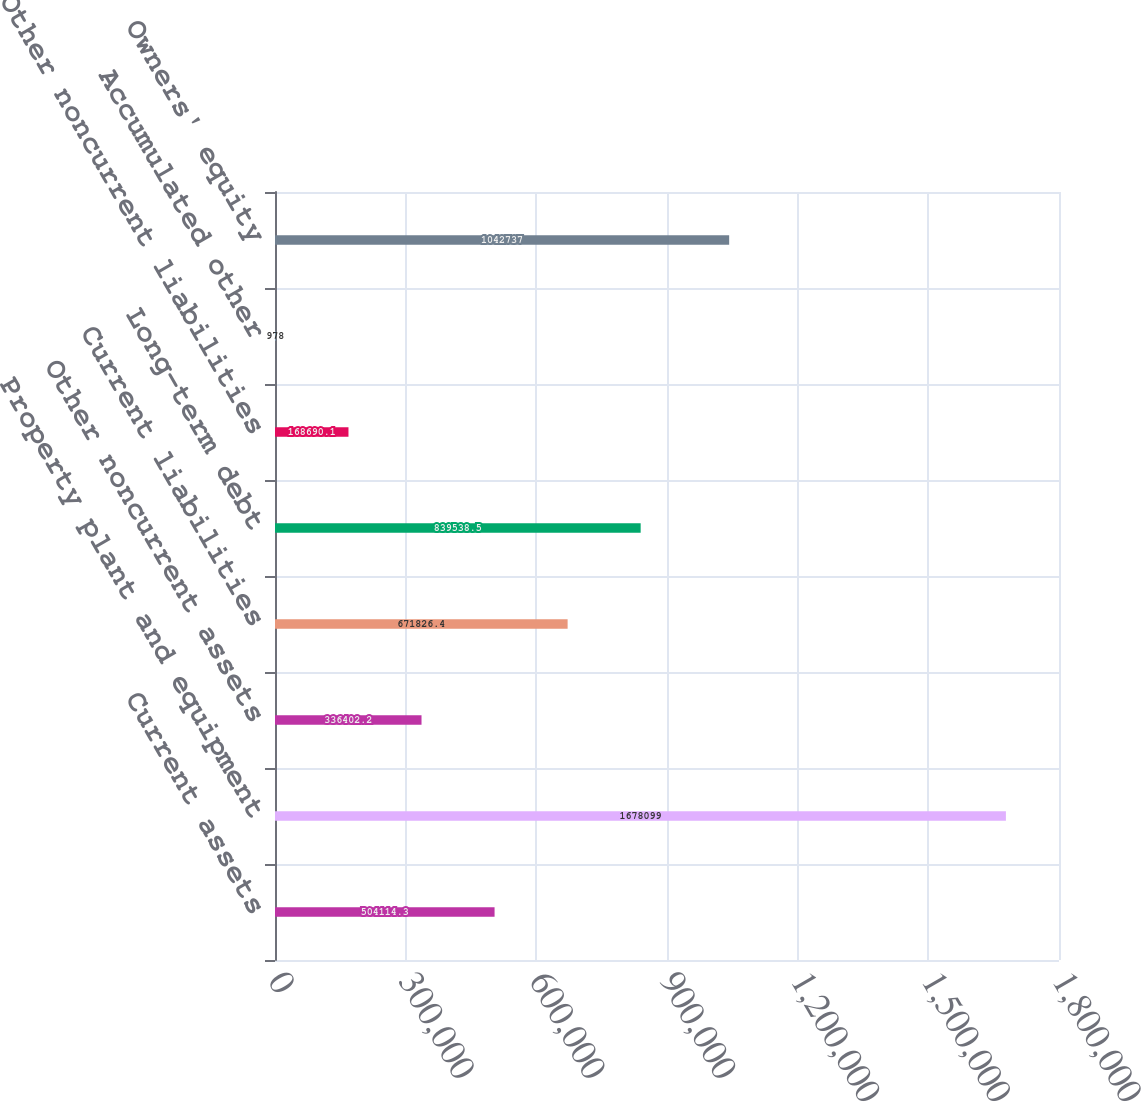<chart> <loc_0><loc_0><loc_500><loc_500><bar_chart><fcel>Current assets<fcel>Property plant and equipment<fcel>Other noncurrent assets<fcel>Current liabilities<fcel>Long-term debt<fcel>Other noncurrent liabilities<fcel>Accumulated other<fcel>Owners' equity<nl><fcel>504114<fcel>1.6781e+06<fcel>336402<fcel>671826<fcel>839538<fcel>168690<fcel>978<fcel>1.04274e+06<nl></chart> 